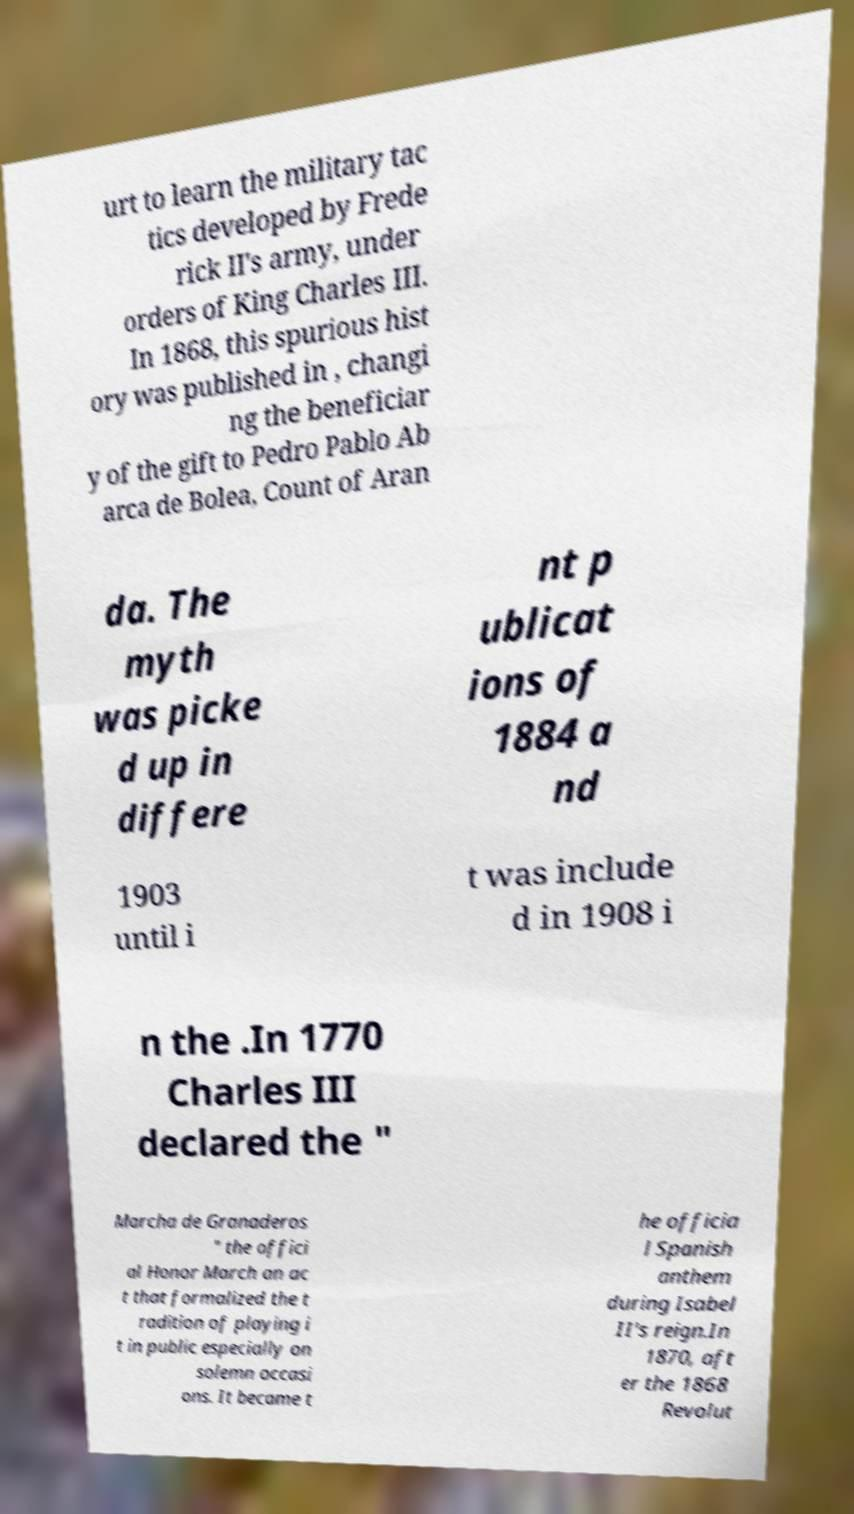There's text embedded in this image that I need extracted. Can you transcribe it verbatim? urt to learn the military tac tics developed by Frede rick II's army, under orders of King Charles III. In 1868, this spurious hist ory was published in , changi ng the beneficiar y of the gift to Pedro Pablo Ab arca de Bolea, Count of Aran da. The myth was picke d up in differe nt p ublicat ions of 1884 a nd 1903 until i t was include d in 1908 i n the .In 1770 Charles III declared the " Marcha de Granaderos " the offici al Honor March an ac t that formalized the t radition of playing i t in public especially on solemn occasi ons. It became t he officia l Spanish anthem during Isabel II's reign.In 1870, aft er the 1868 Revolut 